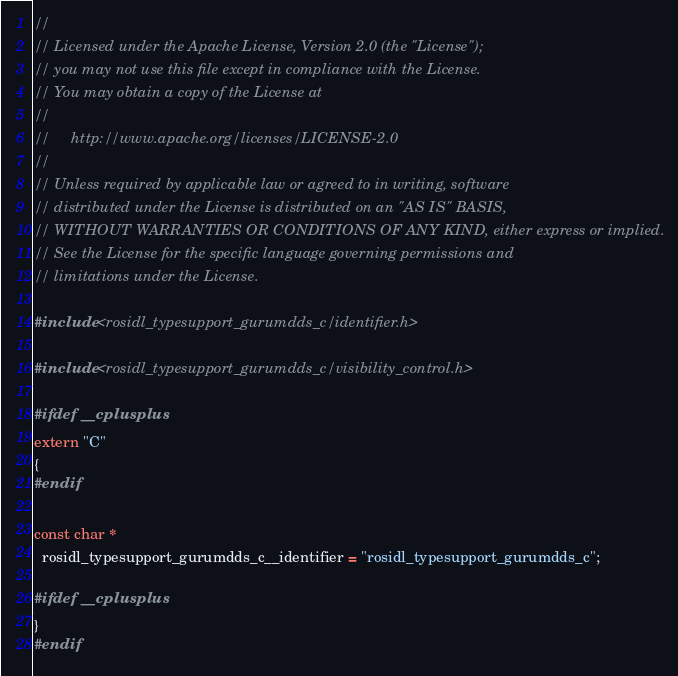Convert code to text. <code><loc_0><loc_0><loc_500><loc_500><_C++_>//
// Licensed under the Apache License, Version 2.0 (the "License");
// you may not use this file except in compliance with the License.
// You may obtain a copy of the License at
//
//     http://www.apache.org/licenses/LICENSE-2.0
//
// Unless required by applicable law or agreed to in writing, software
// distributed under the License is distributed on an "AS IS" BASIS,
// WITHOUT WARRANTIES OR CONDITIONS OF ANY KIND, either express or implied.
// See the License for the specific language governing permissions and
// limitations under the License.

#include <rosidl_typesupport_gurumdds_c/identifier.h>

#include <rosidl_typesupport_gurumdds_c/visibility_control.h>

#ifdef __cplusplus
extern "C"
{
#endif

const char *
  rosidl_typesupport_gurumdds_c__identifier = "rosidl_typesupport_gurumdds_c";

#ifdef __cplusplus
}
#endif
</code> 